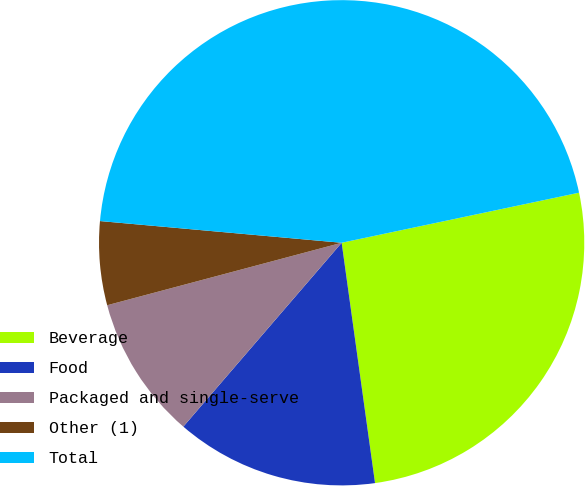Convert chart to OTSL. <chart><loc_0><loc_0><loc_500><loc_500><pie_chart><fcel>Beverage<fcel>Food<fcel>Packaged and single-serve<fcel>Other (1)<fcel>Total<nl><fcel>26.11%<fcel>13.51%<fcel>9.54%<fcel>5.57%<fcel>45.26%<nl></chart> 